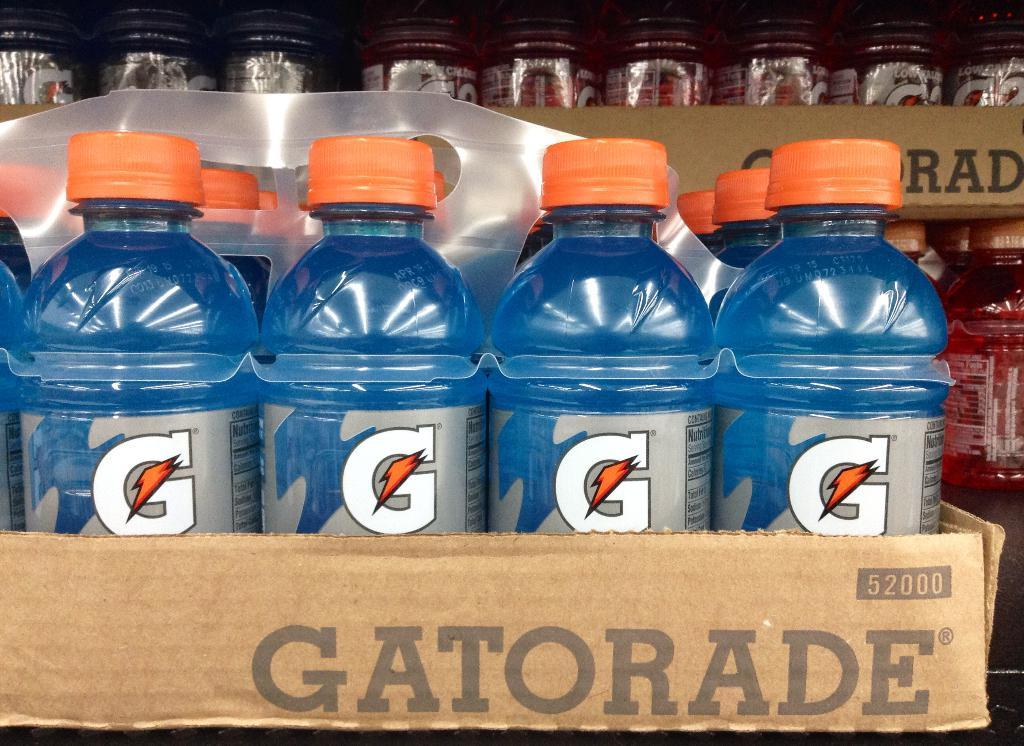<image>
Provide a brief description of the given image. a few bottles of Gatorade that is blue in color 